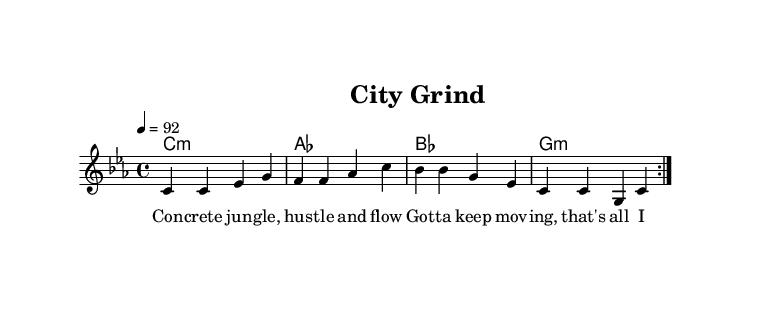What is the key signature of this music? The key signature is indicated at the beginning of the sheet music, showing that it is C minor, which has three flats.
Answer: C minor What is the time signature of the piece? The time signature is found in the first part of the sheet music and it is 4/4, which means there are four beats in each measure.
Answer: 4/4 What is the tempo marking of the music? The tempo marking is given at the beginning of the music with "4 = 92," indicating that there are 92 beats per minute.
Answer: 92 How many times is the melody repeated? The melody section has a repeat section marked with "repeat volta 2," indicating that it is played twice.
Answer: 2 What is the primary theme of the lyrics? The lyrics talk about urban life challenges, specifically focusing on daily struggles with bills and the hustle of city life.
Answer: Urban struggles What chord follows the first melody line? The harmony for the first melody line shows that the first chord is C minor, which corresponds with the melody notes played.
Answer: C minor What genre of music does this piece represent? The lyrics and style of the music reflect elements typical of Rap, which often addresses themes of urban life and personal challenges.
Answer: Rap 